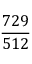<formula> <loc_0><loc_0><loc_500><loc_500>\frac { 7 2 9 } { 5 1 2 }</formula> 